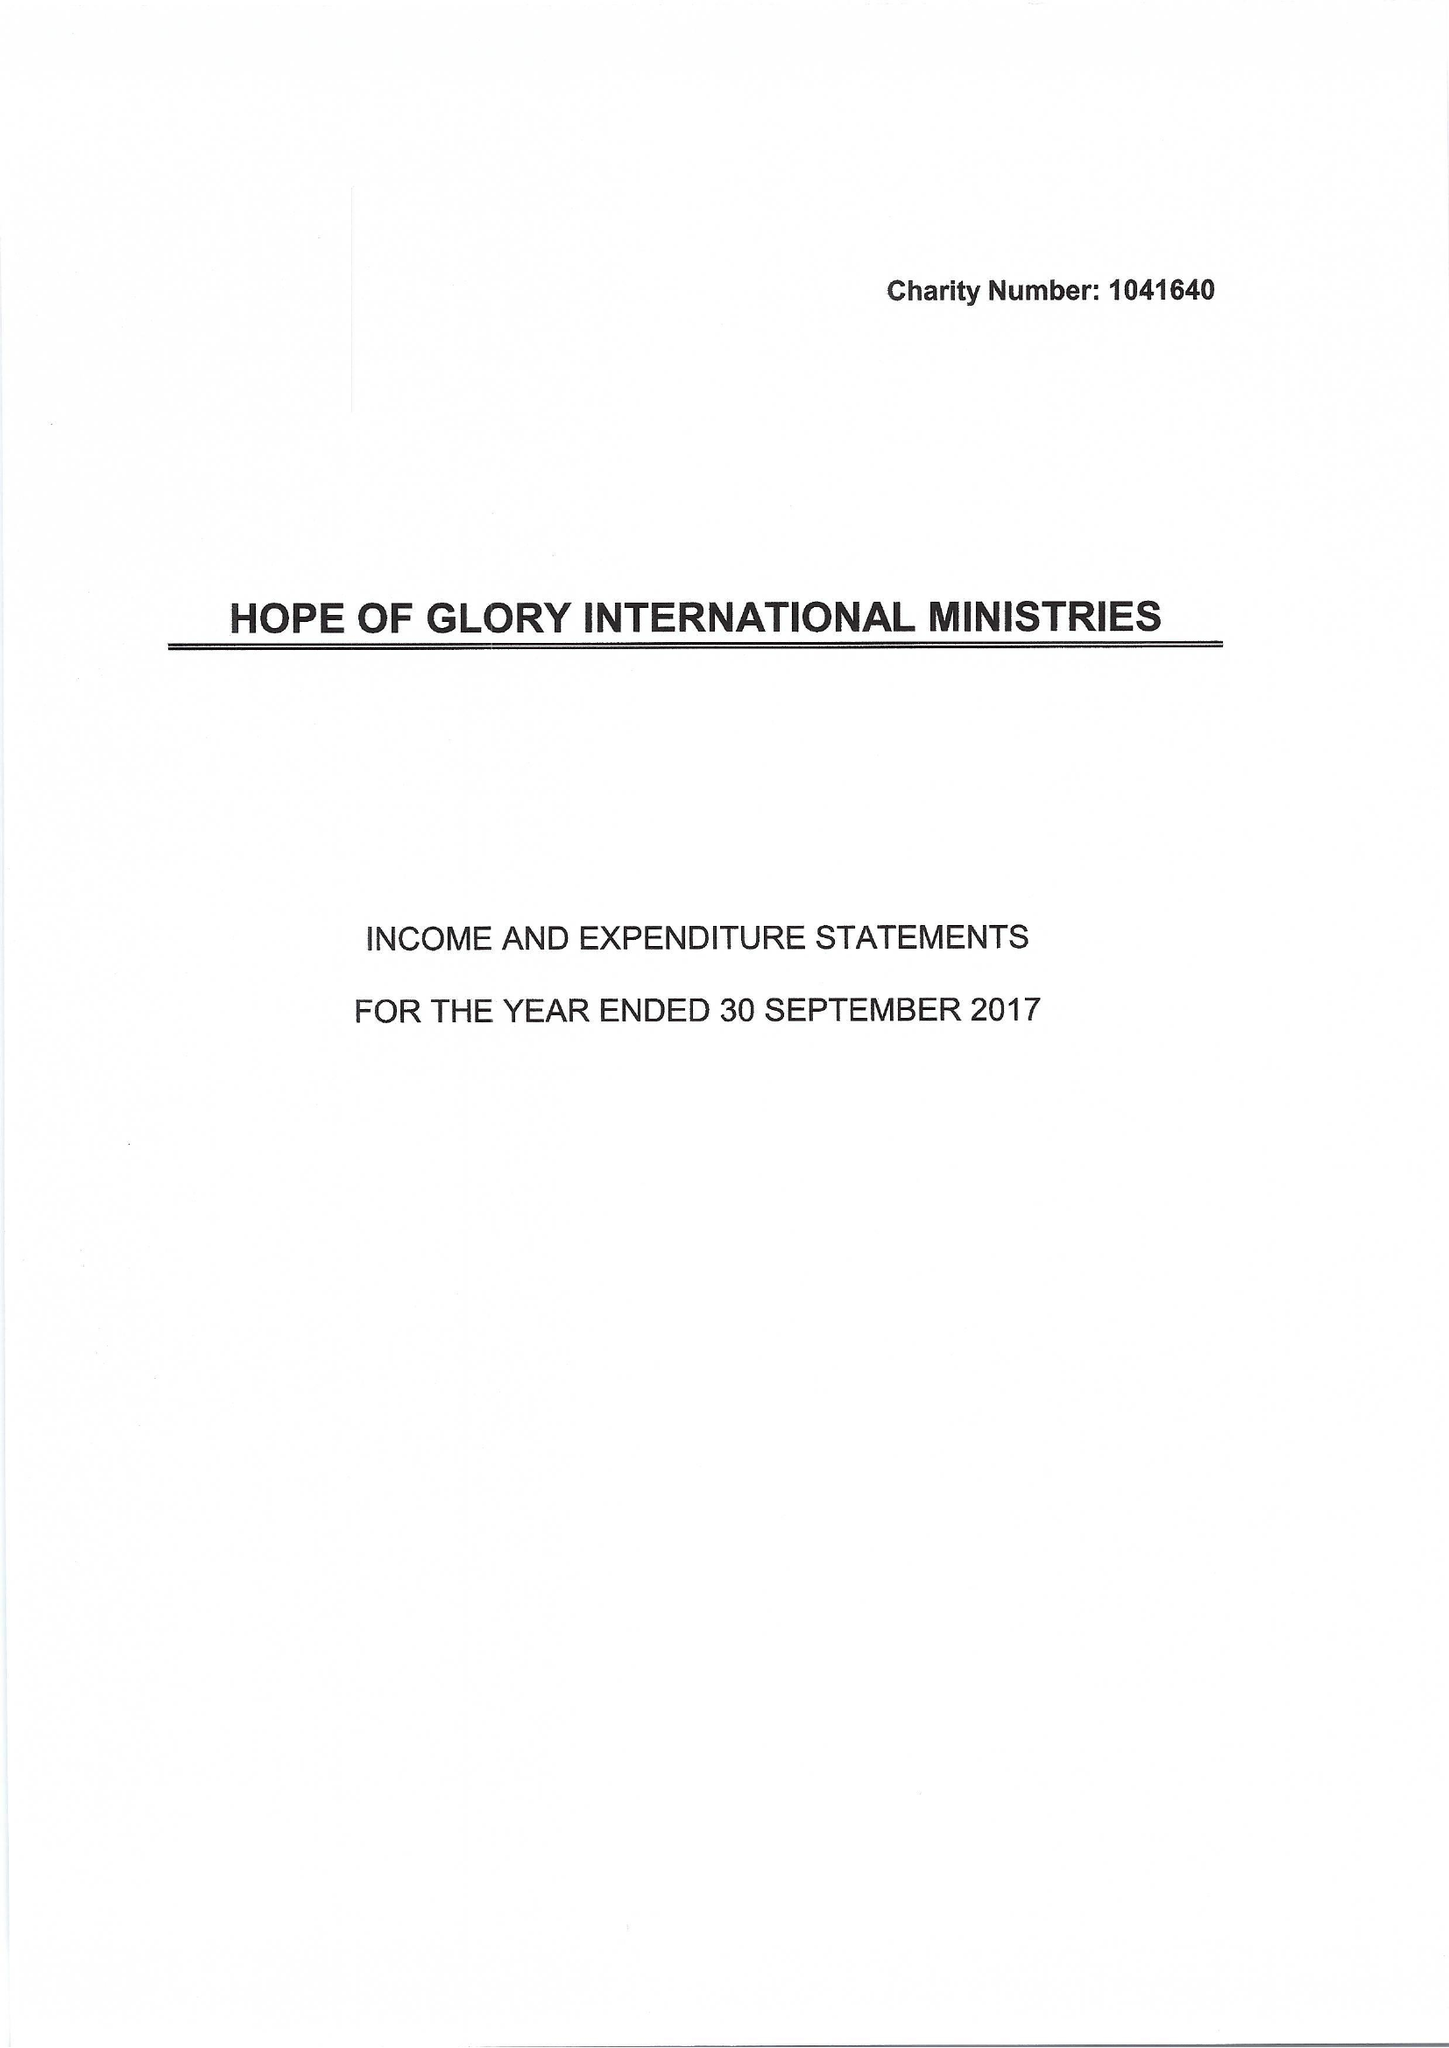What is the value for the income_annually_in_british_pounds?
Answer the question using a single word or phrase. 94587.00 